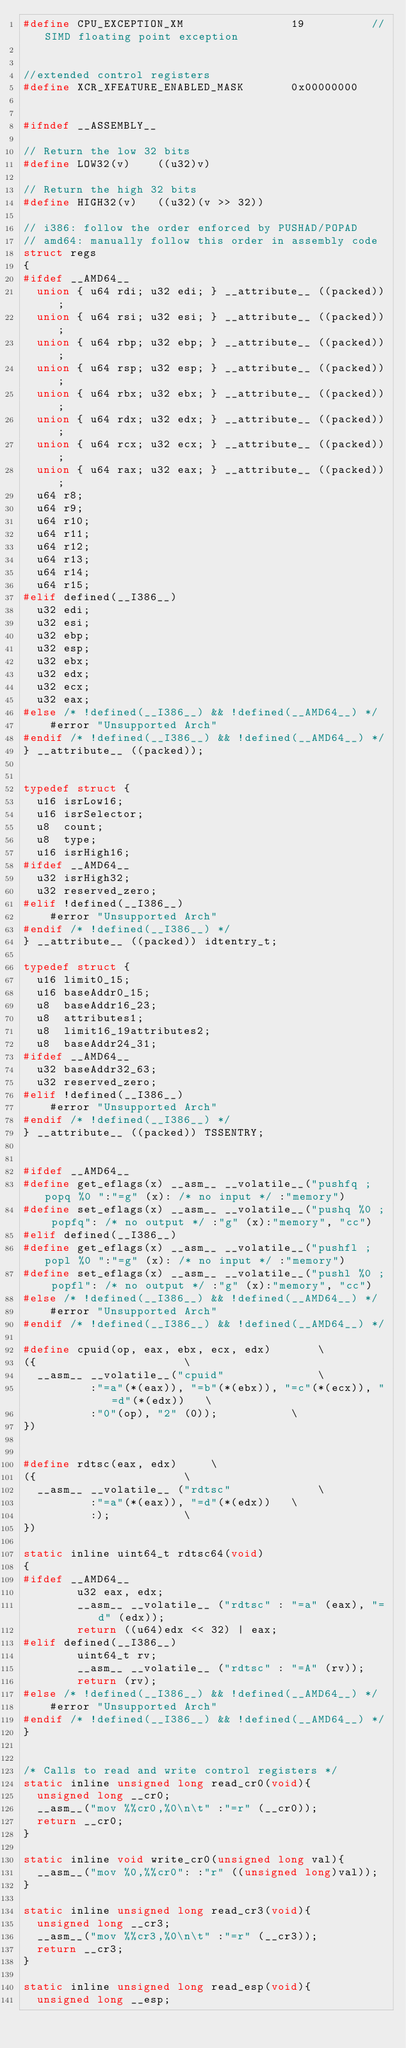<code> <loc_0><loc_0><loc_500><loc_500><_C_>#define CPU_EXCEPTION_XM				19			//SIMD floating point exception


//extended control registers
#define XCR_XFEATURE_ENABLED_MASK       0x00000000


#ifndef __ASSEMBLY__

// Return the low 32 bits
#define LOW32(v)    ((u32)v)

// Return the high 32 bits
#define HIGH32(v)   ((u32)(v >> 32))

// i386: follow the order enforced by PUSHAD/POPAD
// amd64: manually follow this order in assembly code
struct regs
{
#ifdef __AMD64__
  union { u64 rdi; u32 edi; } __attribute__ ((packed));
  union { u64 rsi; u32 esi; } __attribute__ ((packed));
  union { u64 rbp; u32 ebp; } __attribute__ ((packed));
  union { u64 rsp; u32 esp; } __attribute__ ((packed));
  union { u64 rbx; u32 ebx; } __attribute__ ((packed));
  union { u64 rdx; u32 edx; } __attribute__ ((packed));
  union { u64 rcx; u32 ecx; } __attribute__ ((packed));
  union { u64 rax; u32 eax; } __attribute__ ((packed));
  u64 r8;
  u64 r9;
  u64 r10;
  u64 r11;
  u64 r12;
  u64 r13;
  u64 r14;
  u64 r15;
#elif defined(__I386__)
  u32 edi;
  u32 esi;
  u32 ebp;
  u32 esp;
  u32 ebx;
  u32 edx;
  u32 ecx;
  u32 eax;
#else /* !defined(__I386__) && !defined(__AMD64__) */
    #error "Unsupported Arch"
#endif /* !defined(__I386__) && !defined(__AMD64__) */
} __attribute__ ((packed));


typedef struct {
  u16 isrLow16;
  u16 isrSelector;
  u8  count;
  u8  type;
  u16 isrHigh16;
#ifdef __AMD64__
  u32 isrHigh32;
  u32 reserved_zero;
#elif !defined(__I386__)
    #error "Unsupported Arch"
#endif /* !defined(__I386__) */
} __attribute__ ((packed)) idtentry_t;

typedef struct {
  u16 limit0_15;
  u16 baseAddr0_15;
  u8  baseAddr16_23;
  u8  attributes1;
  u8  limit16_19attributes2;
  u8  baseAddr24_31;
#ifdef __AMD64__
  u32 baseAddr32_63;
  u32 reserved_zero;
#elif !defined(__I386__)
    #error "Unsupported Arch"
#endif /* !defined(__I386__) */
} __attribute__ ((packed)) TSSENTRY;


#ifdef __AMD64__
#define get_eflags(x) __asm__ __volatile__("pushfq ; popq %0 ":"=g" (x): /* no input */ :"memory")
#define set_eflags(x) __asm__ __volatile__("pushq %0 ; popfq": /* no output */ :"g" (x):"memory", "cc")
#elif defined(__I386__)
#define get_eflags(x) __asm__ __volatile__("pushfl ; popl %0 ":"=g" (x): /* no input */ :"memory")
#define set_eflags(x) __asm__ __volatile__("pushl %0 ; popfl": /* no output */ :"g" (x):"memory", "cc")
#else /* !defined(__I386__) && !defined(__AMD64__) */
    #error "Unsupported Arch"
#endif /* !defined(__I386__) && !defined(__AMD64__) */

#define cpuid(op, eax, ebx, ecx, edx)		\
({						\
  __asm__ __volatile__("cpuid"				\
          :"=a"(*(eax)), "=b"(*(ebx)), "=c"(*(ecx)), "=d"(*(edx))	\
          :"0"(op), "2" (0));			\
})


#define rdtsc(eax, edx)		\
({						\
  __asm__ __volatile__ ("rdtsc"				\
          :"=a"(*(eax)), "=d"(*(edx))	\
          :);			\
})

static inline uint64_t rdtsc64(void)
{
#ifdef __AMD64__
        u32 eax, edx;
        __asm__ __volatile__ ("rdtsc" : "=a" (eax), "=d" (edx));
        return ((u64)edx << 32) | eax;
#elif defined(__I386__)
        uint64_t rv;
        __asm__ __volatile__ ("rdtsc" : "=A" (rv));
        return (rv);
#else /* !defined(__I386__) && !defined(__AMD64__) */
    #error "Unsupported Arch"
#endif /* !defined(__I386__) && !defined(__AMD64__) */
}


/* Calls to read and write control registers */
static inline unsigned long read_cr0(void){
  unsigned long __cr0;
  __asm__("mov %%cr0,%0\n\t" :"=r" (__cr0));
  return __cr0;
}

static inline void write_cr0(unsigned long val){
  __asm__("mov %0,%%cr0": :"r" ((unsigned long)val));
}

static inline unsigned long read_cr3(void){
  unsigned long __cr3;
  __asm__("mov %%cr3,%0\n\t" :"=r" (__cr3));
  return __cr3;
}

static inline unsigned long read_esp(void){
  unsigned long __esp;</code> 